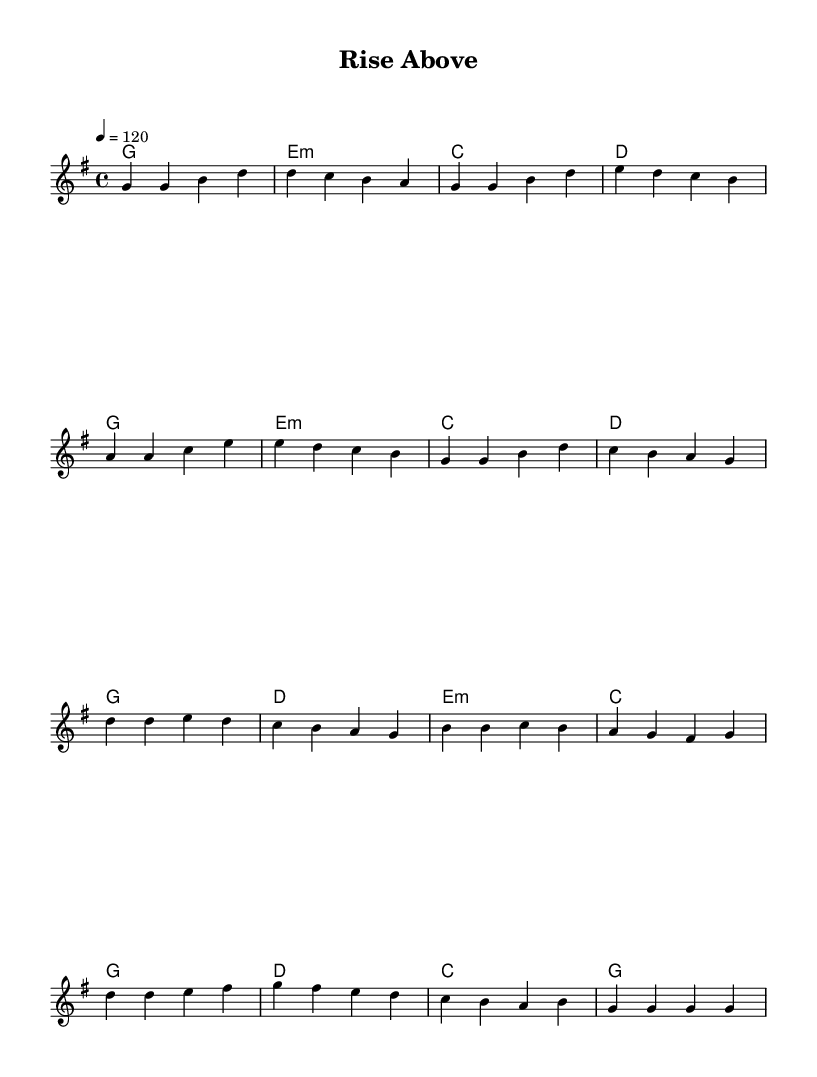What is the key signature of this music? The key signature is G major, which has one sharp (F#). This can be identified at the beginning of the staff, where the sharp is indicated.
Answer: G major What is the time signature of this music? The time signature is 4/4, which can be found at the beginning of the sheet music notated as '4/4' right after the key signature. This indicates there are four beats in a measure and a quarter note gets one beat.
Answer: 4/4 What is the tempo marking in this piece? The tempo marking is 120, shown at the top of the sheet music as "4 = 120". This indicates the speed of the music, referring to the number of beats per minute (bpm).
Answer: 120 How many measures are in the verse section? The verse section consists of 8 measures, which can be counted from the beginning of the verse notation until the end before the chorus starts.
Answer: 8 What is the main theme of the lyrics as indicated in the sheet music? The main theme of the lyrics focuses on overcoming challenges and growth, which is evident in phrases like "facing challenges head on" and "we'll rise above". This is highlighted throughout the verse and chorus.
Answer: Overcoming challenges What chord appears at the beginning of the chorus? The chord that appears at the beginning of the chorus is G major, which is indicated by the notation in the chord mode section corresponding to the music melody for the chorus starting.
Answer: G Which notes are played in the second half of the chorus? The notes played in the second half of the chorus are E, D, C, and G, as shown in the melodic line for the second part of the chorus after the phrase "putting on a show".
Answer: E, D, C, G 